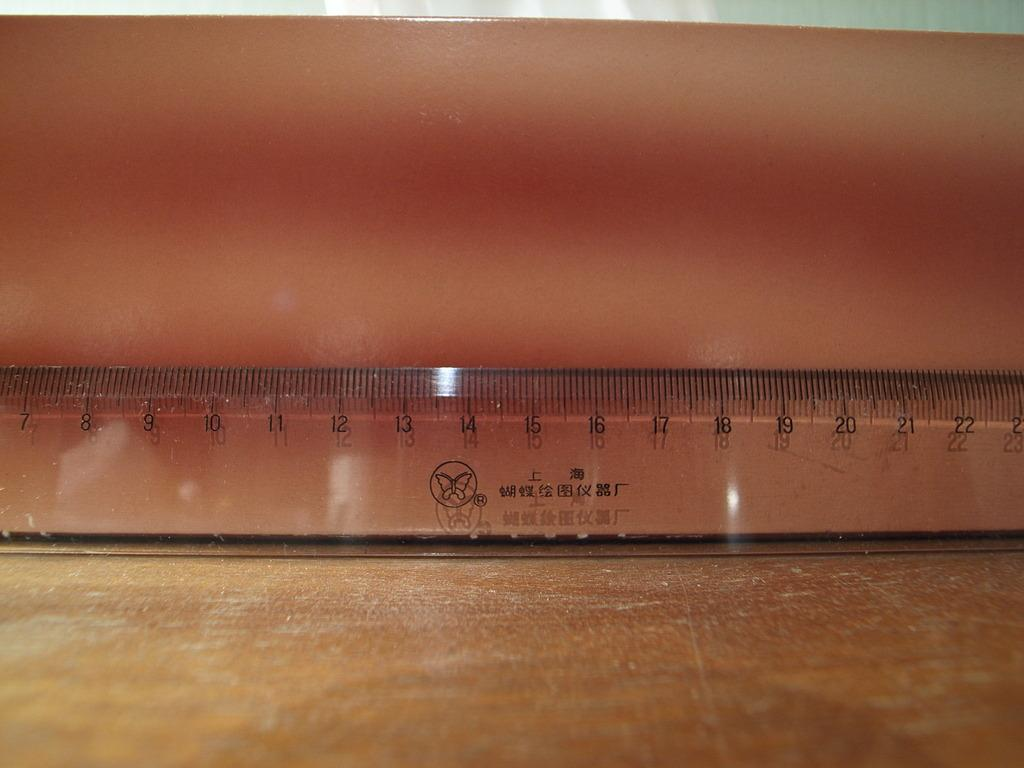What object is present in the image that can be used for measuring? There is a measuring scale in the image. Where is the measuring scale located? The measuring scale is on a table. What time does the clock show on the oven in the image? There is no clock or oven present in the image; it only features a measuring scale on a table. 